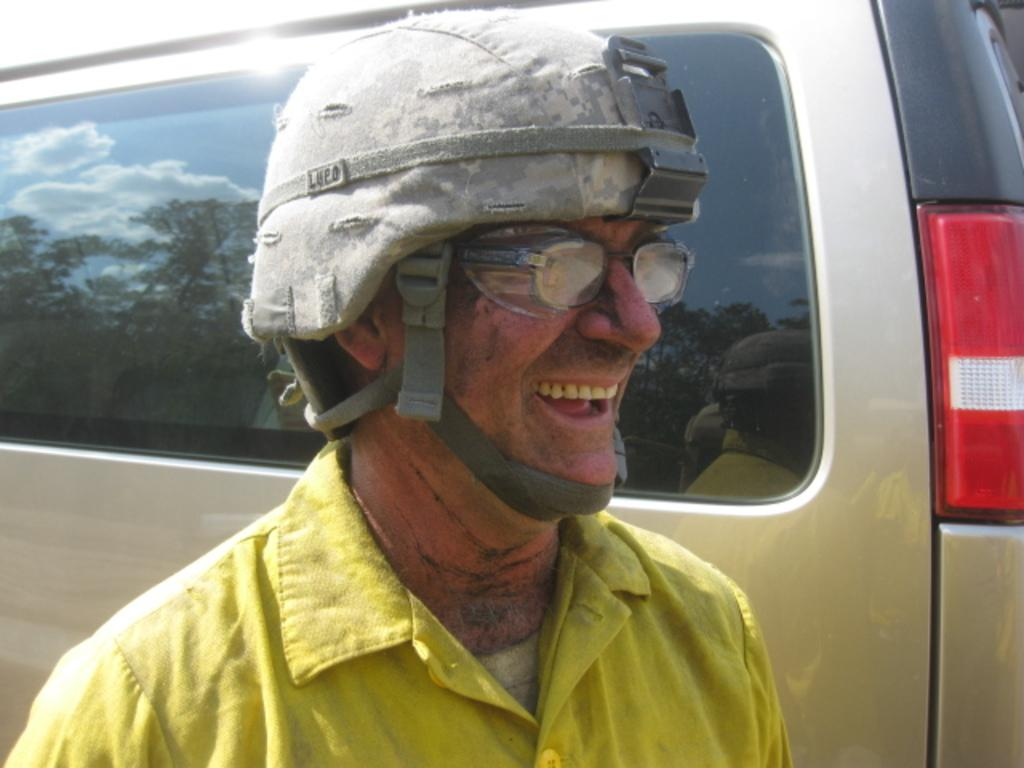Who is present in the image? There is a man in the image. What is the man doing in the image? The man is smiling in the image. What is the man wearing on his upper body? The man is wearing a yellow shirt in the image. What type of protective gear is the man wearing? The man is wearing a helmet in the image. What vehicle can be seen in the image? There is a car visible in the image. What type of cannon is the man using to shoot goldfish in the image? There is no cannon or goldfish present in the image. 